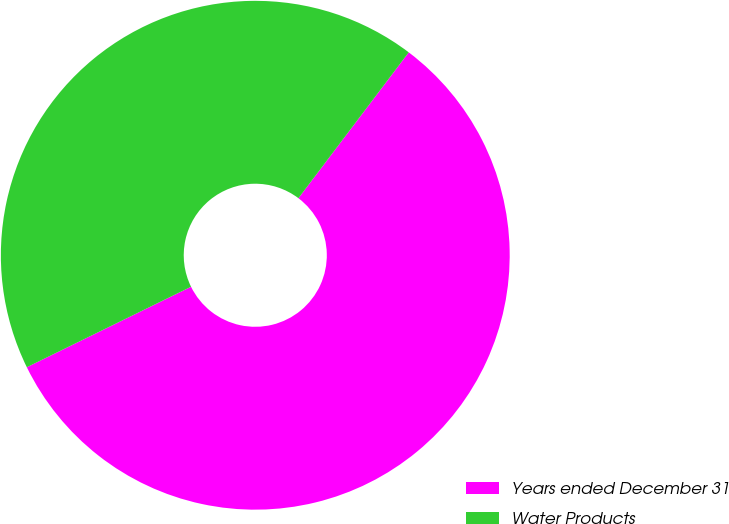<chart> <loc_0><loc_0><loc_500><loc_500><pie_chart><fcel>Years ended December 31<fcel>Water Products<nl><fcel>57.44%<fcel>42.56%<nl></chart> 